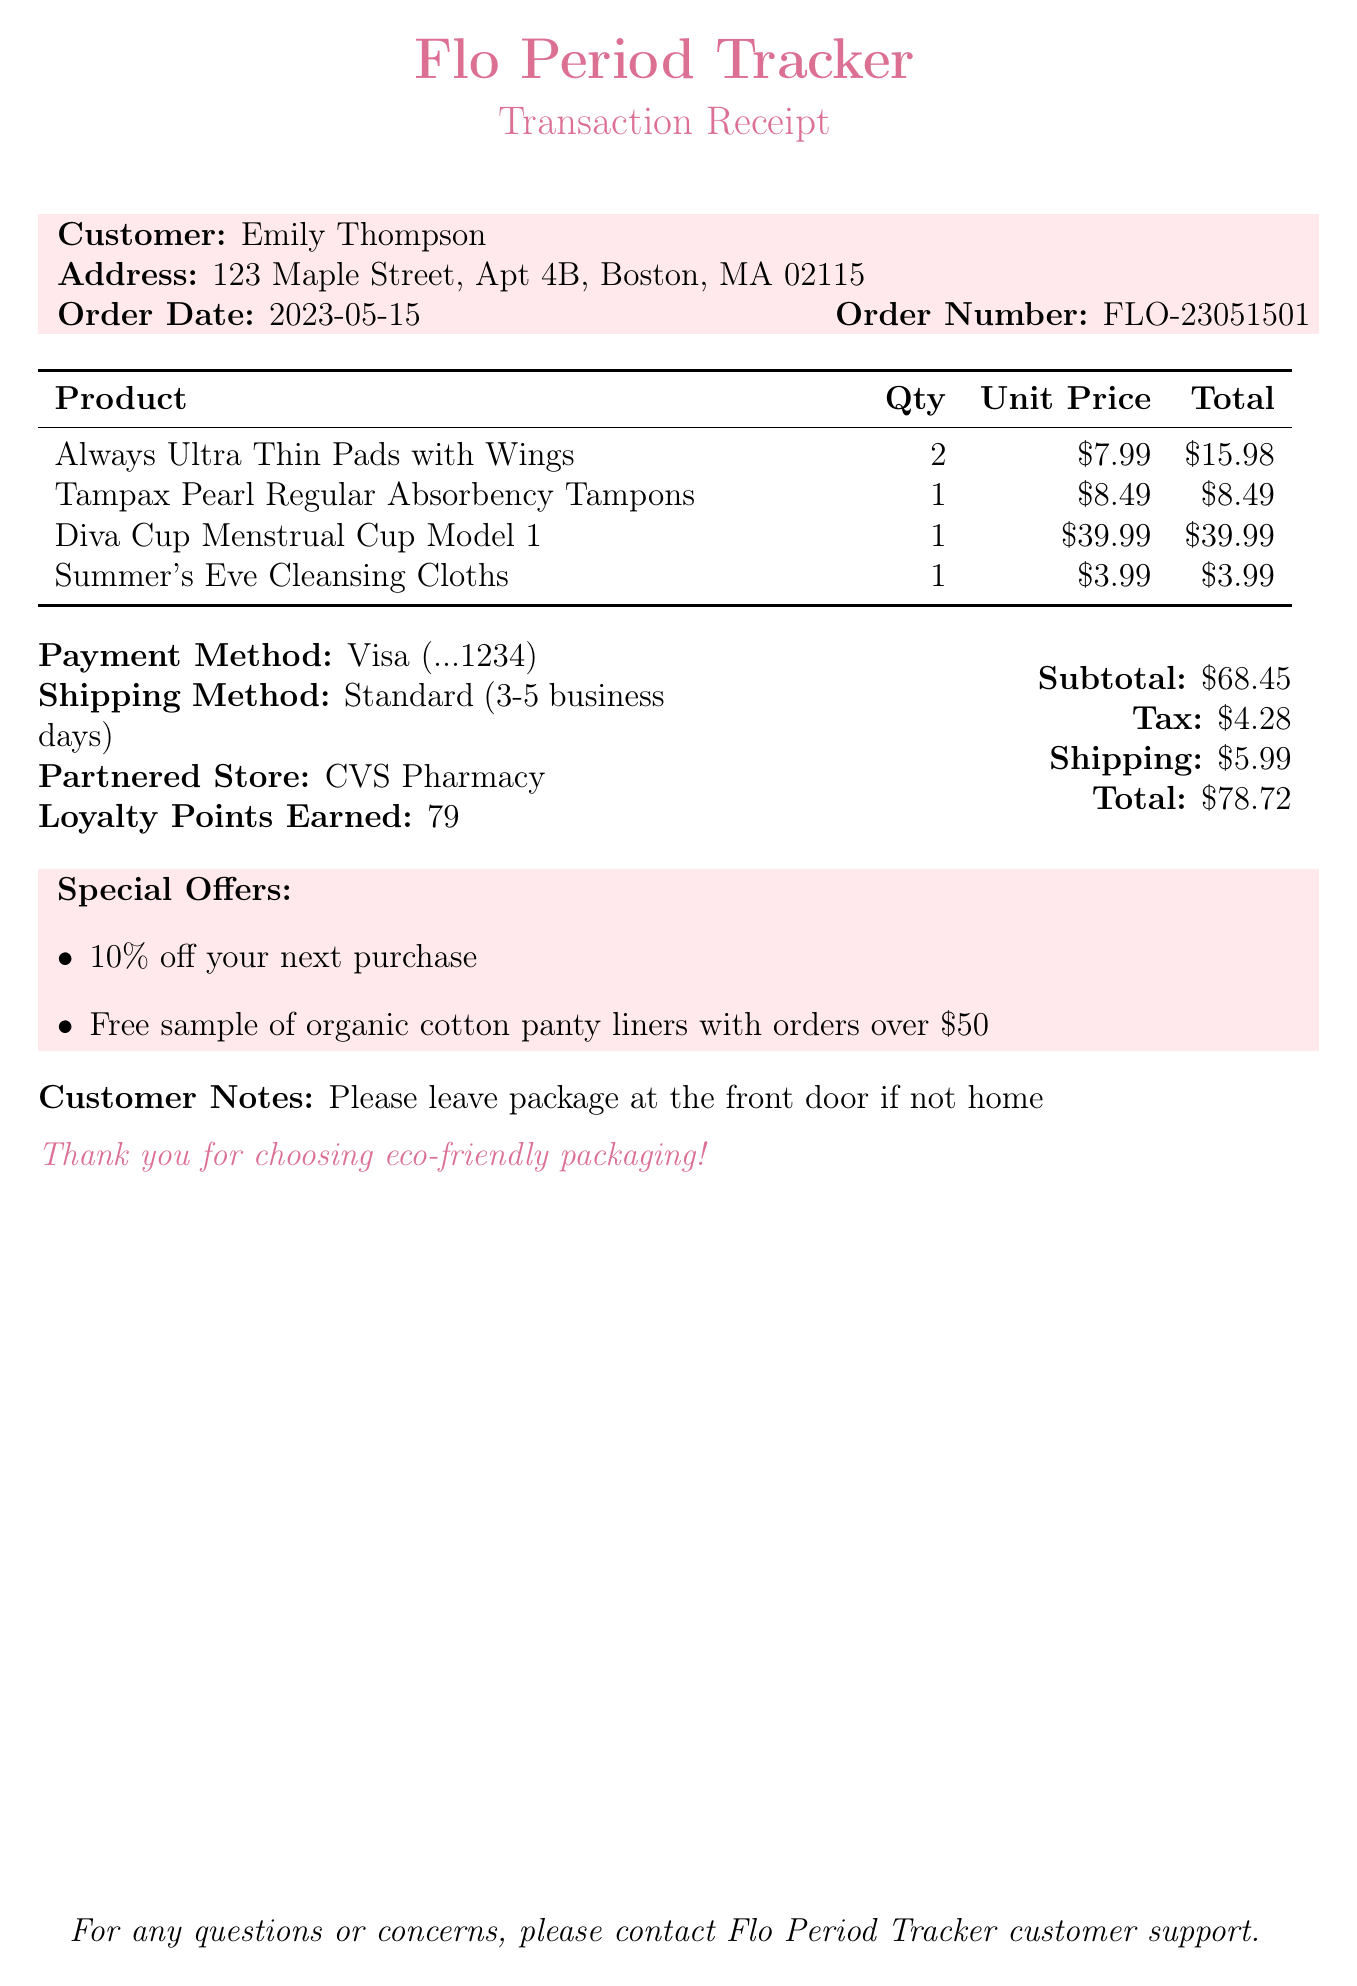what is the customer's name? The customer's name is provided at the beginning of the document.
Answer: Emily Thompson what is the order date? The order date is specified in the document under the order details.
Answer: 2023-05-15 how many items did the customer purchase? The number of items is indicated by counting the entries in the items list.
Answer: 4 what is the total amount paid? The total amount is specified in the payment summary section of the document.
Answer: $78.72 what payment method was used? The payment method is detailed under the payment section of the document.
Answer: Credit Card what promotion can the customer use for their next purchase? The special offers are included towards the end of the document, specifically mentioning a discount.
Answer: 10% off your next purchase what is the shipping method? The shipping method is indicated in the shipping section of the document.
Answer: Standard (3-5 business days) how many loyalty points did the customer earn? The total loyalty points are mentioned in the payment summary section of the document.
Answer: 79 what is the customer's note for delivery? The note is included under the customer notes section of the document.
Answer: Please leave package at the front door if not home 